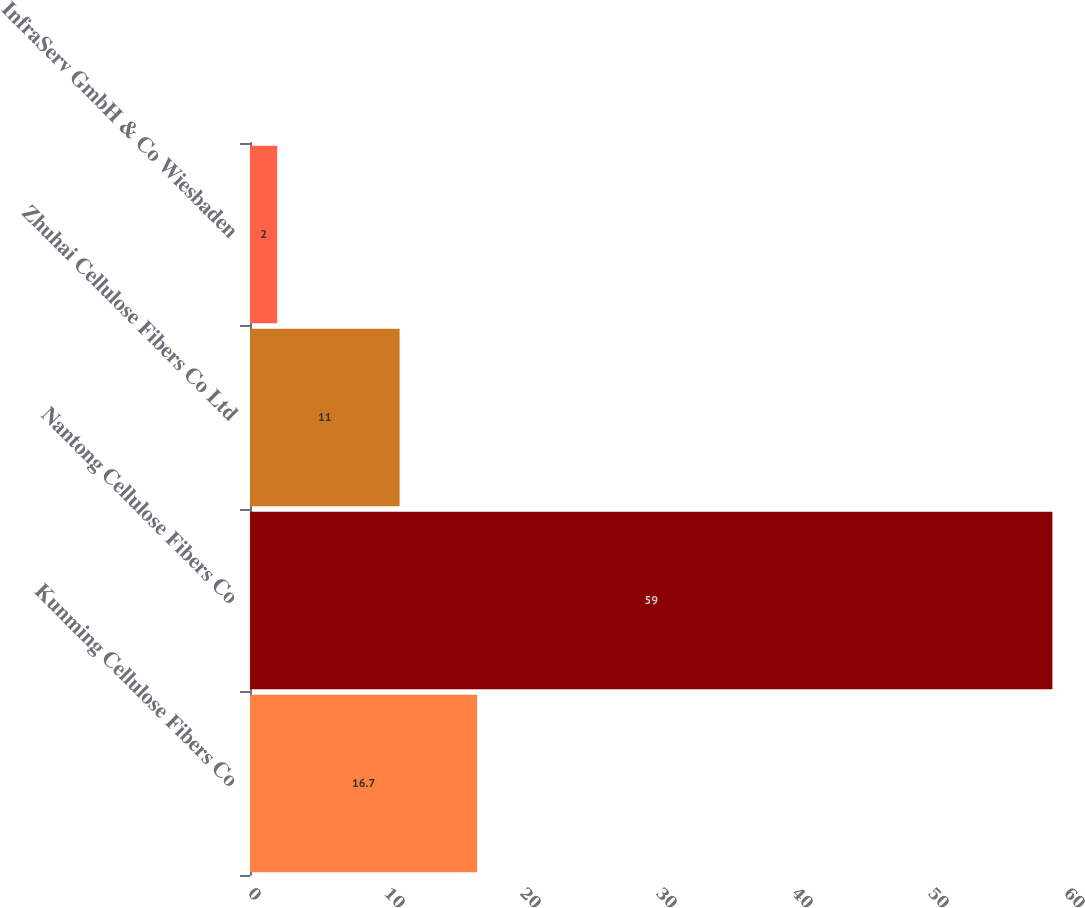<chart> <loc_0><loc_0><loc_500><loc_500><bar_chart><fcel>Kunming Cellulose Fibers Co<fcel>Nantong Cellulose Fibers Co<fcel>Zhuhai Cellulose Fibers Co Ltd<fcel>InfraServ GmbH & Co Wiesbaden<nl><fcel>16.7<fcel>59<fcel>11<fcel>2<nl></chart> 